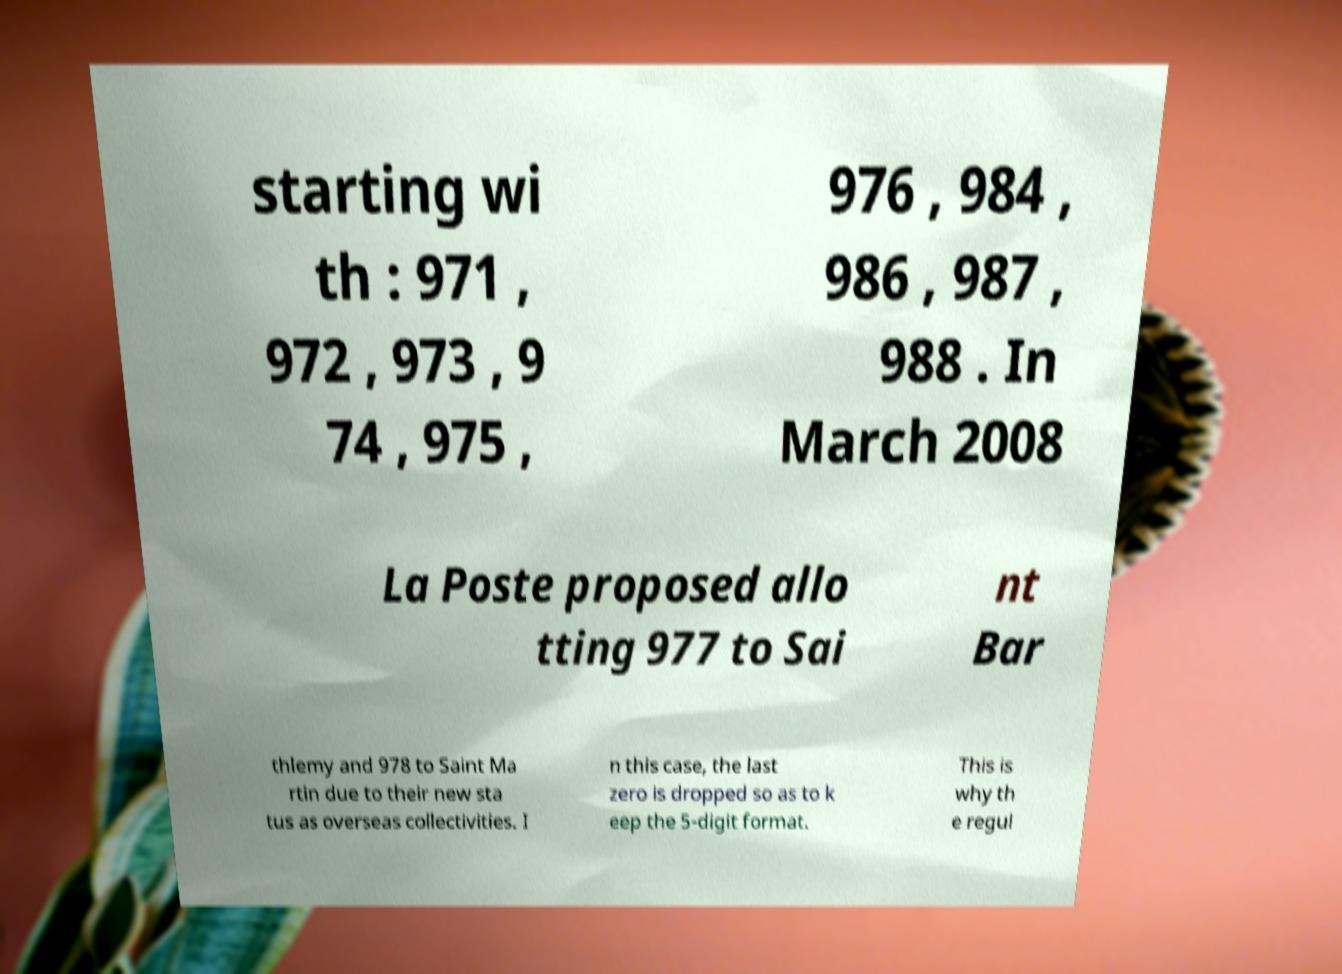Please read and relay the text visible in this image. What does it say? starting wi th : 971 , 972 , 973 , 9 74 , 975 , 976 , 984 , 986 , 987 , 988 . In March 2008 La Poste proposed allo tting 977 to Sai nt Bar thlemy and 978 to Saint Ma rtin due to their new sta tus as overseas collectivities. I n this case, the last zero is dropped so as to k eep the 5-digit format. This is why th e regul 